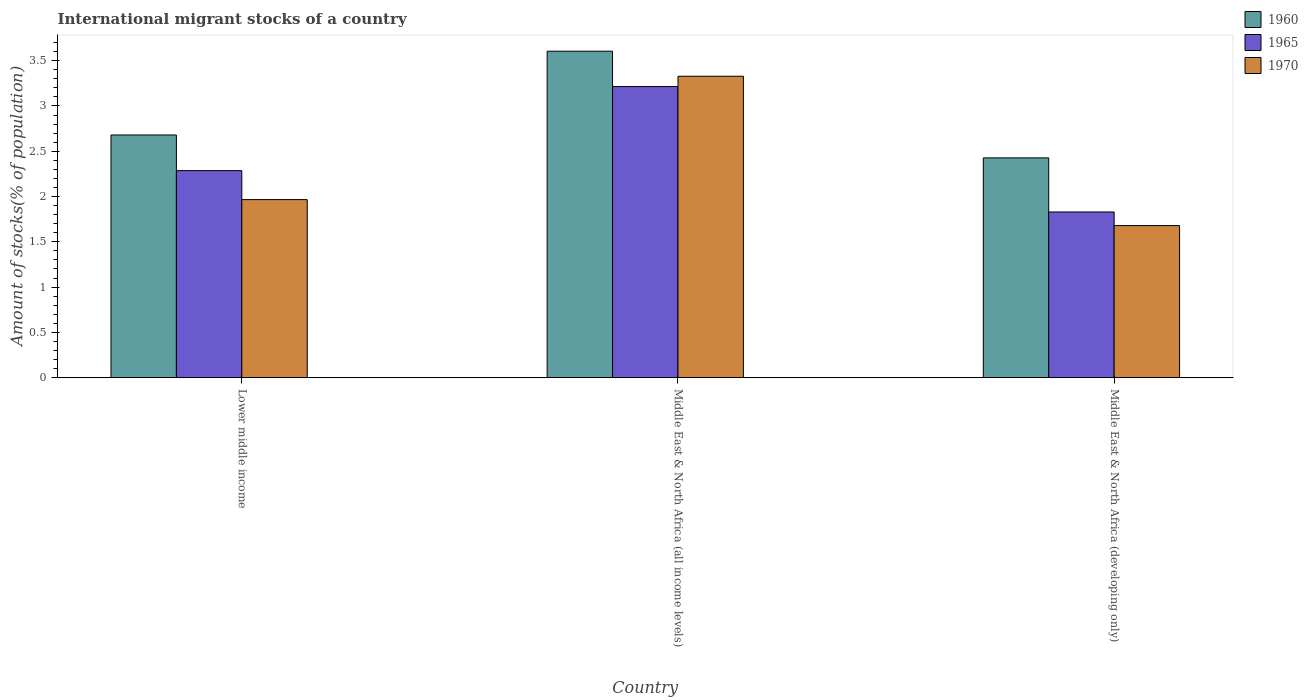Are the number of bars per tick equal to the number of legend labels?
Provide a succinct answer. Yes. Are the number of bars on each tick of the X-axis equal?
Offer a terse response. Yes. What is the label of the 2nd group of bars from the left?
Your answer should be compact. Middle East & North Africa (all income levels). What is the amount of stocks in in 1965 in Lower middle income?
Your answer should be compact. 2.29. Across all countries, what is the maximum amount of stocks in in 1965?
Provide a succinct answer. 3.21. Across all countries, what is the minimum amount of stocks in in 1960?
Your response must be concise. 2.43. In which country was the amount of stocks in in 1970 maximum?
Provide a short and direct response. Middle East & North Africa (all income levels). In which country was the amount of stocks in in 1960 minimum?
Your response must be concise. Middle East & North Africa (developing only). What is the total amount of stocks in in 1965 in the graph?
Provide a short and direct response. 7.33. What is the difference between the amount of stocks in in 1960 in Middle East & North Africa (all income levels) and that in Middle East & North Africa (developing only)?
Offer a terse response. 1.18. What is the difference between the amount of stocks in in 1965 in Middle East & North Africa (all income levels) and the amount of stocks in in 1960 in Middle East & North Africa (developing only)?
Give a very brief answer. 0.79. What is the average amount of stocks in in 1960 per country?
Ensure brevity in your answer.  2.9. What is the difference between the amount of stocks in of/in 1970 and amount of stocks in of/in 1965 in Middle East & North Africa (developing only)?
Offer a very short reply. -0.15. In how many countries, is the amount of stocks in in 1965 greater than 3 %?
Your response must be concise. 1. What is the ratio of the amount of stocks in in 1960 in Lower middle income to that in Middle East & North Africa (all income levels)?
Ensure brevity in your answer.  0.74. Is the amount of stocks in in 1960 in Lower middle income less than that in Middle East & North Africa (all income levels)?
Your answer should be very brief. Yes. What is the difference between the highest and the second highest amount of stocks in in 1965?
Offer a very short reply. -0.46. What is the difference between the highest and the lowest amount of stocks in in 1965?
Your answer should be compact. 1.38. In how many countries, is the amount of stocks in in 1965 greater than the average amount of stocks in in 1965 taken over all countries?
Ensure brevity in your answer.  1. Is the sum of the amount of stocks in in 1970 in Lower middle income and Middle East & North Africa (all income levels) greater than the maximum amount of stocks in in 1965 across all countries?
Make the answer very short. Yes. What does the 1st bar from the left in Middle East & North Africa (all income levels) represents?
Provide a short and direct response. 1960. What does the 1st bar from the right in Middle East & North Africa (developing only) represents?
Your answer should be very brief. 1970. Is it the case that in every country, the sum of the amount of stocks in in 1970 and amount of stocks in in 1960 is greater than the amount of stocks in in 1965?
Your answer should be very brief. Yes. Are all the bars in the graph horizontal?
Give a very brief answer. No. How many countries are there in the graph?
Provide a short and direct response. 3. Does the graph contain grids?
Provide a short and direct response. No. What is the title of the graph?
Offer a terse response. International migrant stocks of a country. Does "2004" appear as one of the legend labels in the graph?
Offer a terse response. No. What is the label or title of the X-axis?
Give a very brief answer. Country. What is the label or title of the Y-axis?
Give a very brief answer. Amount of stocks(% of population). What is the Amount of stocks(% of population) in 1960 in Lower middle income?
Offer a very short reply. 2.68. What is the Amount of stocks(% of population) in 1965 in Lower middle income?
Offer a very short reply. 2.29. What is the Amount of stocks(% of population) of 1970 in Lower middle income?
Your answer should be very brief. 1.97. What is the Amount of stocks(% of population) of 1960 in Middle East & North Africa (all income levels)?
Make the answer very short. 3.6. What is the Amount of stocks(% of population) in 1965 in Middle East & North Africa (all income levels)?
Your answer should be compact. 3.21. What is the Amount of stocks(% of population) of 1970 in Middle East & North Africa (all income levels)?
Your response must be concise. 3.33. What is the Amount of stocks(% of population) of 1960 in Middle East & North Africa (developing only)?
Give a very brief answer. 2.43. What is the Amount of stocks(% of population) in 1965 in Middle East & North Africa (developing only)?
Give a very brief answer. 1.83. What is the Amount of stocks(% of population) of 1970 in Middle East & North Africa (developing only)?
Your response must be concise. 1.68. Across all countries, what is the maximum Amount of stocks(% of population) in 1960?
Offer a terse response. 3.6. Across all countries, what is the maximum Amount of stocks(% of population) of 1965?
Offer a very short reply. 3.21. Across all countries, what is the maximum Amount of stocks(% of population) of 1970?
Make the answer very short. 3.33. Across all countries, what is the minimum Amount of stocks(% of population) of 1960?
Ensure brevity in your answer.  2.43. Across all countries, what is the minimum Amount of stocks(% of population) in 1965?
Offer a terse response. 1.83. Across all countries, what is the minimum Amount of stocks(% of population) of 1970?
Provide a succinct answer. 1.68. What is the total Amount of stocks(% of population) in 1960 in the graph?
Your answer should be compact. 8.71. What is the total Amount of stocks(% of population) of 1965 in the graph?
Give a very brief answer. 7.33. What is the total Amount of stocks(% of population) of 1970 in the graph?
Provide a succinct answer. 6.97. What is the difference between the Amount of stocks(% of population) in 1960 in Lower middle income and that in Middle East & North Africa (all income levels)?
Your answer should be very brief. -0.93. What is the difference between the Amount of stocks(% of population) of 1965 in Lower middle income and that in Middle East & North Africa (all income levels)?
Keep it short and to the point. -0.93. What is the difference between the Amount of stocks(% of population) of 1970 in Lower middle income and that in Middle East & North Africa (all income levels)?
Make the answer very short. -1.36. What is the difference between the Amount of stocks(% of population) of 1960 in Lower middle income and that in Middle East & North Africa (developing only)?
Give a very brief answer. 0.25. What is the difference between the Amount of stocks(% of population) in 1965 in Lower middle income and that in Middle East & North Africa (developing only)?
Keep it short and to the point. 0.46. What is the difference between the Amount of stocks(% of population) in 1970 in Lower middle income and that in Middle East & North Africa (developing only)?
Provide a short and direct response. 0.29. What is the difference between the Amount of stocks(% of population) in 1960 in Middle East & North Africa (all income levels) and that in Middle East & North Africa (developing only)?
Give a very brief answer. 1.18. What is the difference between the Amount of stocks(% of population) of 1965 in Middle East & North Africa (all income levels) and that in Middle East & North Africa (developing only)?
Ensure brevity in your answer.  1.38. What is the difference between the Amount of stocks(% of population) of 1970 in Middle East & North Africa (all income levels) and that in Middle East & North Africa (developing only)?
Provide a succinct answer. 1.65. What is the difference between the Amount of stocks(% of population) in 1960 in Lower middle income and the Amount of stocks(% of population) in 1965 in Middle East & North Africa (all income levels)?
Your answer should be compact. -0.53. What is the difference between the Amount of stocks(% of population) of 1960 in Lower middle income and the Amount of stocks(% of population) of 1970 in Middle East & North Africa (all income levels)?
Offer a very short reply. -0.65. What is the difference between the Amount of stocks(% of population) of 1965 in Lower middle income and the Amount of stocks(% of population) of 1970 in Middle East & North Africa (all income levels)?
Offer a terse response. -1.04. What is the difference between the Amount of stocks(% of population) in 1960 in Lower middle income and the Amount of stocks(% of population) in 1965 in Middle East & North Africa (developing only)?
Give a very brief answer. 0.85. What is the difference between the Amount of stocks(% of population) of 1965 in Lower middle income and the Amount of stocks(% of population) of 1970 in Middle East & North Africa (developing only)?
Offer a very short reply. 0.61. What is the difference between the Amount of stocks(% of population) in 1960 in Middle East & North Africa (all income levels) and the Amount of stocks(% of population) in 1965 in Middle East & North Africa (developing only)?
Your answer should be very brief. 1.78. What is the difference between the Amount of stocks(% of population) in 1960 in Middle East & North Africa (all income levels) and the Amount of stocks(% of population) in 1970 in Middle East & North Africa (developing only)?
Offer a very short reply. 1.93. What is the difference between the Amount of stocks(% of population) of 1965 in Middle East & North Africa (all income levels) and the Amount of stocks(% of population) of 1970 in Middle East & North Africa (developing only)?
Your answer should be compact. 1.53. What is the average Amount of stocks(% of population) of 1960 per country?
Give a very brief answer. 2.9. What is the average Amount of stocks(% of population) of 1965 per country?
Your answer should be compact. 2.44. What is the average Amount of stocks(% of population) in 1970 per country?
Keep it short and to the point. 2.32. What is the difference between the Amount of stocks(% of population) of 1960 and Amount of stocks(% of population) of 1965 in Lower middle income?
Your answer should be very brief. 0.39. What is the difference between the Amount of stocks(% of population) in 1960 and Amount of stocks(% of population) in 1970 in Lower middle income?
Keep it short and to the point. 0.71. What is the difference between the Amount of stocks(% of population) of 1965 and Amount of stocks(% of population) of 1970 in Lower middle income?
Your response must be concise. 0.32. What is the difference between the Amount of stocks(% of population) of 1960 and Amount of stocks(% of population) of 1965 in Middle East & North Africa (all income levels)?
Offer a terse response. 0.39. What is the difference between the Amount of stocks(% of population) in 1960 and Amount of stocks(% of population) in 1970 in Middle East & North Africa (all income levels)?
Ensure brevity in your answer.  0.28. What is the difference between the Amount of stocks(% of population) of 1965 and Amount of stocks(% of population) of 1970 in Middle East & North Africa (all income levels)?
Provide a succinct answer. -0.11. What is the difference between the Amount of stocks(% of population) in 1960 and Amount of stocks(% of population) in 1965 in Middle East & North Africa (developing only)?
Your answer should be compact. 0.6. What is the difference between the Amount of stocks(% of population) in 1960 and Amount of stocks(% of population) in 1970 in Middle East & North Africa (developing only)?
Your answer should be compact. 0.75. What is the difference between the Amount of stocks(% of population) in 1965 and Amount of stocks(% of population) in 1970 in Middle East & North Africa (developing only)?
Give a very brief answer. 0.15. What is the ratio of the Amount of stocks(% of population) of 1960 in Lower middle income to that in Middle East & North Africa (all income levels)?
Ensure brevity in your answer.  0.74. What is the ratio of the Amount of stocks(% of population) of 1965 in Lower middle income to that in Middle East & North Africa (all income levels)?
Make the answer very short. 0.71. What is the ratio of the Amount of stocks(% of population) of 1970 in Lower middle income to that in Middle East & North Africa (all income levels)?
Your answer should be compact. 0.59. What is the ratio of the Amount of stocks(% of population) in 1960 in Lower middle income to that in Middle East & North Africa (developing only)?
Keep it short and to the point. 1.1. What is the ratio of the Amount of stocks(% of population) of 1965 in Lower middle income to that in Middle East & North Africa (developing only)?
Your answer should be very brief. 1.25. What is the ratio of the Amount of stocks(% of population) in 1970 in Lower middle income to that in Middle East & North Africa (developing only)?
Your response must be concise. 1.17. What is the ratio of the Amount of stocks(% of population) in 1960 in Middle East & North Africa (all income levels) to that in Middle East & North Africa (developing only)?
Your response must be concise. 1.49. What is the ratio of the Amount of stocks(% of population) of 1965 in Middle East & North Africa (all income levels) to that in Middle East & North Africa (developing only)?
Keep it short and to the point. 1.76. What is the ratio of the Amount of stocks(% of population) of 1970 in Middle East & North Africa (all income levels) to that in Middle East & North Africa (developing only)?
Provide a short and direct response. 1.98. What is the difference between the highest and the second highest Amount of stocks(% of population) in 1960?
Offer a terse response. 0.93. What is the difference between the highest and the second highest Amount of stocks(% of population) in 1965?
Offer a terse response. 0.93. What is the difference between the highest and the second highest Amount of stocks(% of population) in 1970?
Provide a succinct answer. 1.36. What is the difference between the highest and the lowest Amount of stocks(% of population) of 1960?
Make the answer very short. 1.18. What is the difference between the highest and the lowest Amount of stocks(% of population) of 1965?
Give a very brief answer. 1.38. What is the difference between the highest and the lowest Amount of stocks(% of population) in 1970?
Give a very brief answer. 1.65. 